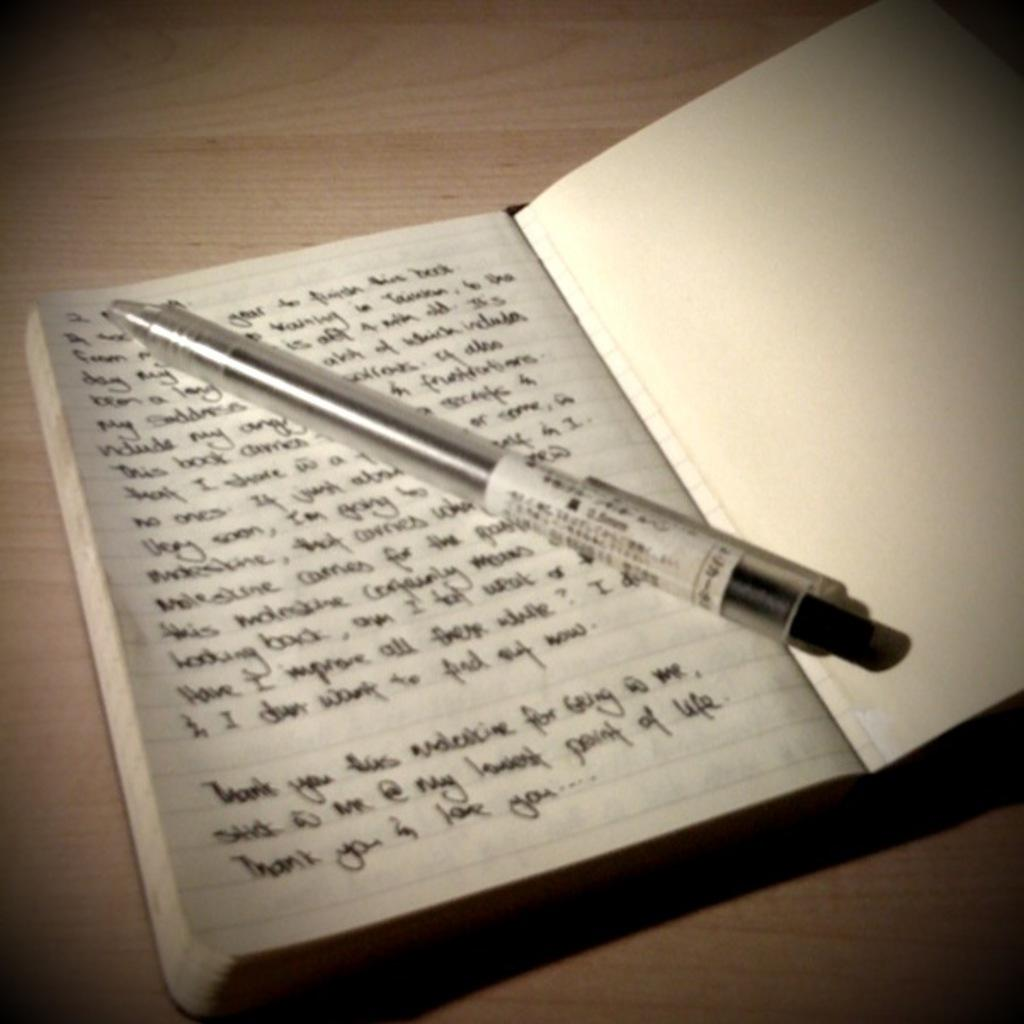What color is the table in the image? The table in the image is cream-colored. What object is placed on the table? There is a book on the table. Is there any text or writing on the book? Yes, something is written on the book. What is placed on top of the book? There is a pen on the book. What type of juice can be seen being poured from the clam in the image? There is no clam or juice present in the image; it features a cream-colored table with a book and a pen. 